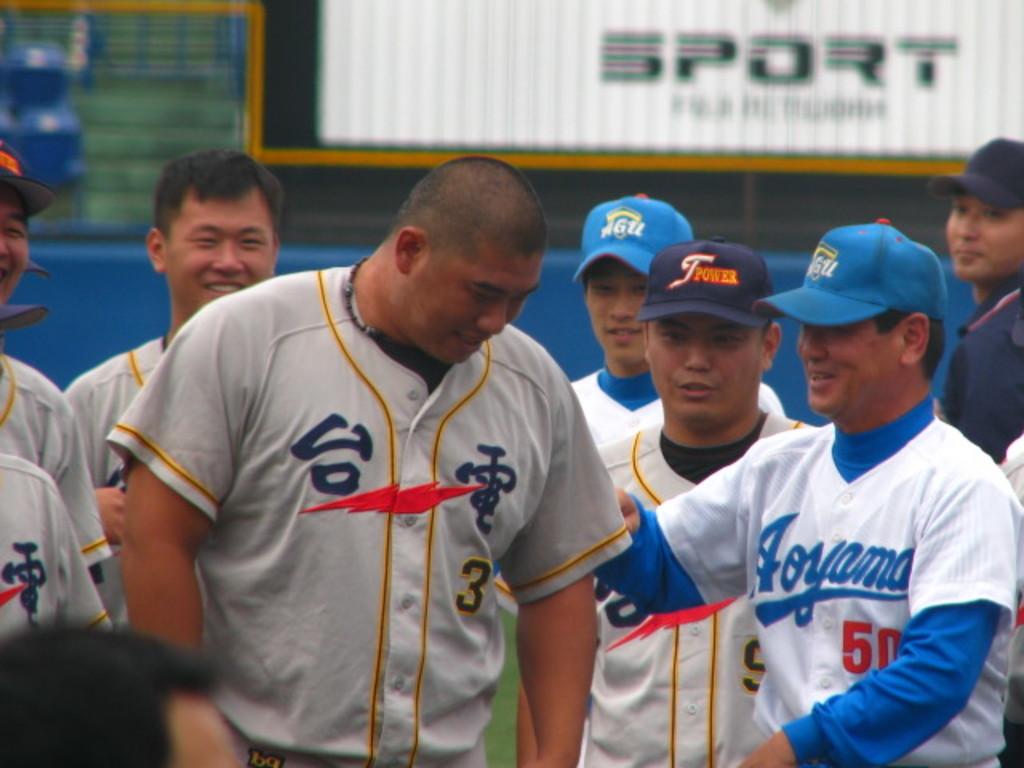Which team is wearing white?
Provide a succinct answer. Aoyama. 